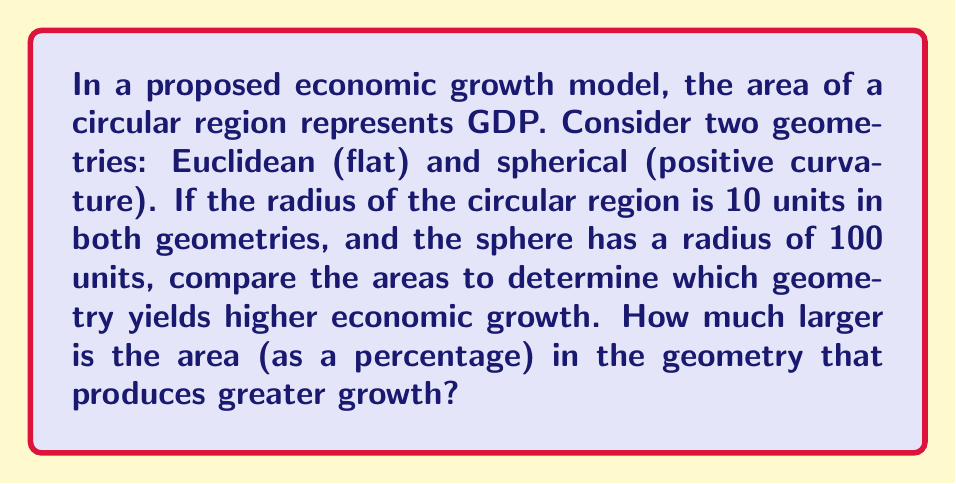Give your solution to this math problem. Let's approach this step-by-step:

1) In Euclidean geometry, the area of a circle is given by:
   $$A_E = \pi r^2$$

2) In spherical geometry, the area of a circle is given by:
   $$A_S = 4\pi R^2 \sin^2(\frac{r}{2R})$$
   where $R$ is the radius of the sphere and $r$ is the radius of the circle.

3) Let's calculate the Euclidean area:
   $$A_E = \pi (10)^2 = 100\pi \approx 314.16$$

4) Now, let's calculate the spherical area:
   $$A_S = 4\pi (100)^2 \sin^2(\frac{10}{2(100)}) = 40000\pi \sin^2(0.05)$$
   $$A_S = 40000\pi (0.049979)^2 \approx 313.66$$

5) To compare, we calculate the percentage difference:
   $$\text{Percentage Difference} = \frac{A_E - A_S}{A_S} \times 100\%$$
   $$= \frac{314.16 - 313.66}{313.66} \times 100\% \approx 0.16\%$$

This model suggests that the Euclidean geometry yields slightly higher economic growth.

[asy]
import geometry;

size(200);
draw(circle((0,0),10));
label("Euclidean", (0,-12));

draw(circle((25,0),10));
draw(arc((25,0),10,0,360),dashed);
label("Spherical", (25,-12));
draw(arc((25,-100),100,80,100));
[/asy]
Answer: Euclidean geometry yields 0.16% larger area, indicating higher economic growth. 